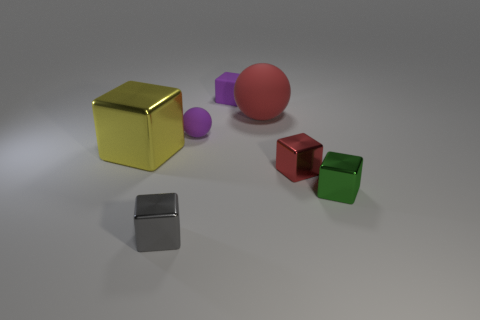Can you tell me the colors of the cubes present in this image? Certainly! In the image, there are cubes in gold, red, green, and a tiny red one which could be considered either red or metal due to its sheen. 